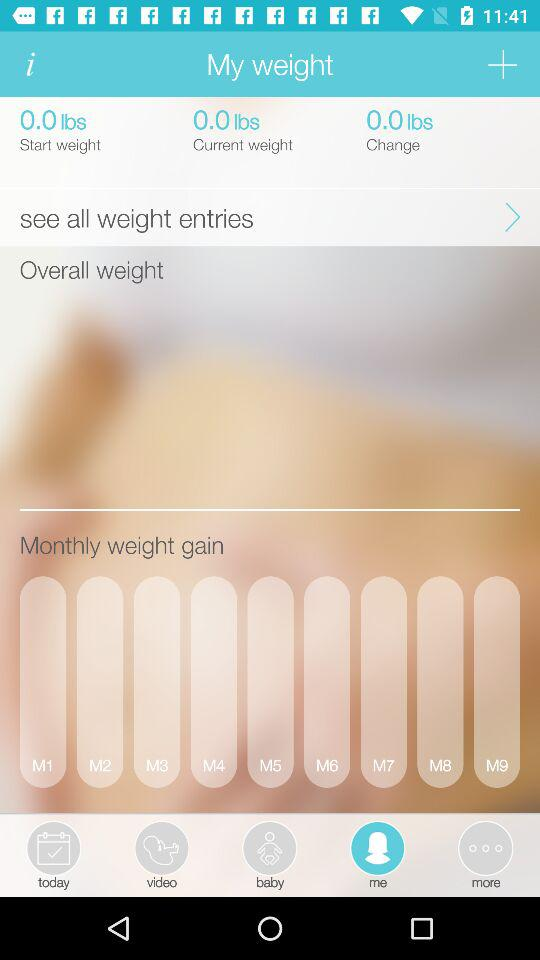How many months of weight entries are there?
Answer the question using a single word or phrase. 9 